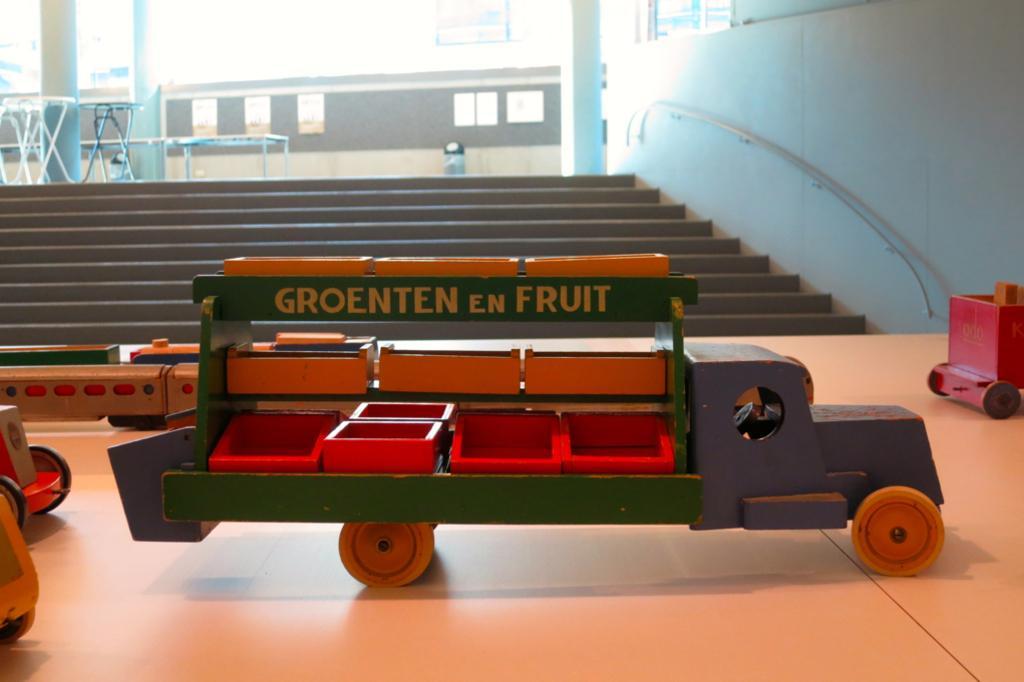Please provide a concise description of this image. In this picture in the front there are toy vehicles and there is a text written on the vehicle which is in the center. In the background there are steps and there are empty tables and there are empty benches, there is a wall and on the right side of the wall there is a rod and there are windows. 